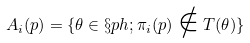Convert formula to latex. <formula><loc_0><loc_0><loc_500><loc_500>A _ { i } ( p ) = \{ \theta \in \S p h ; \pi _ { i } ( p ) \notin T ( \theta ) \}</formula> 